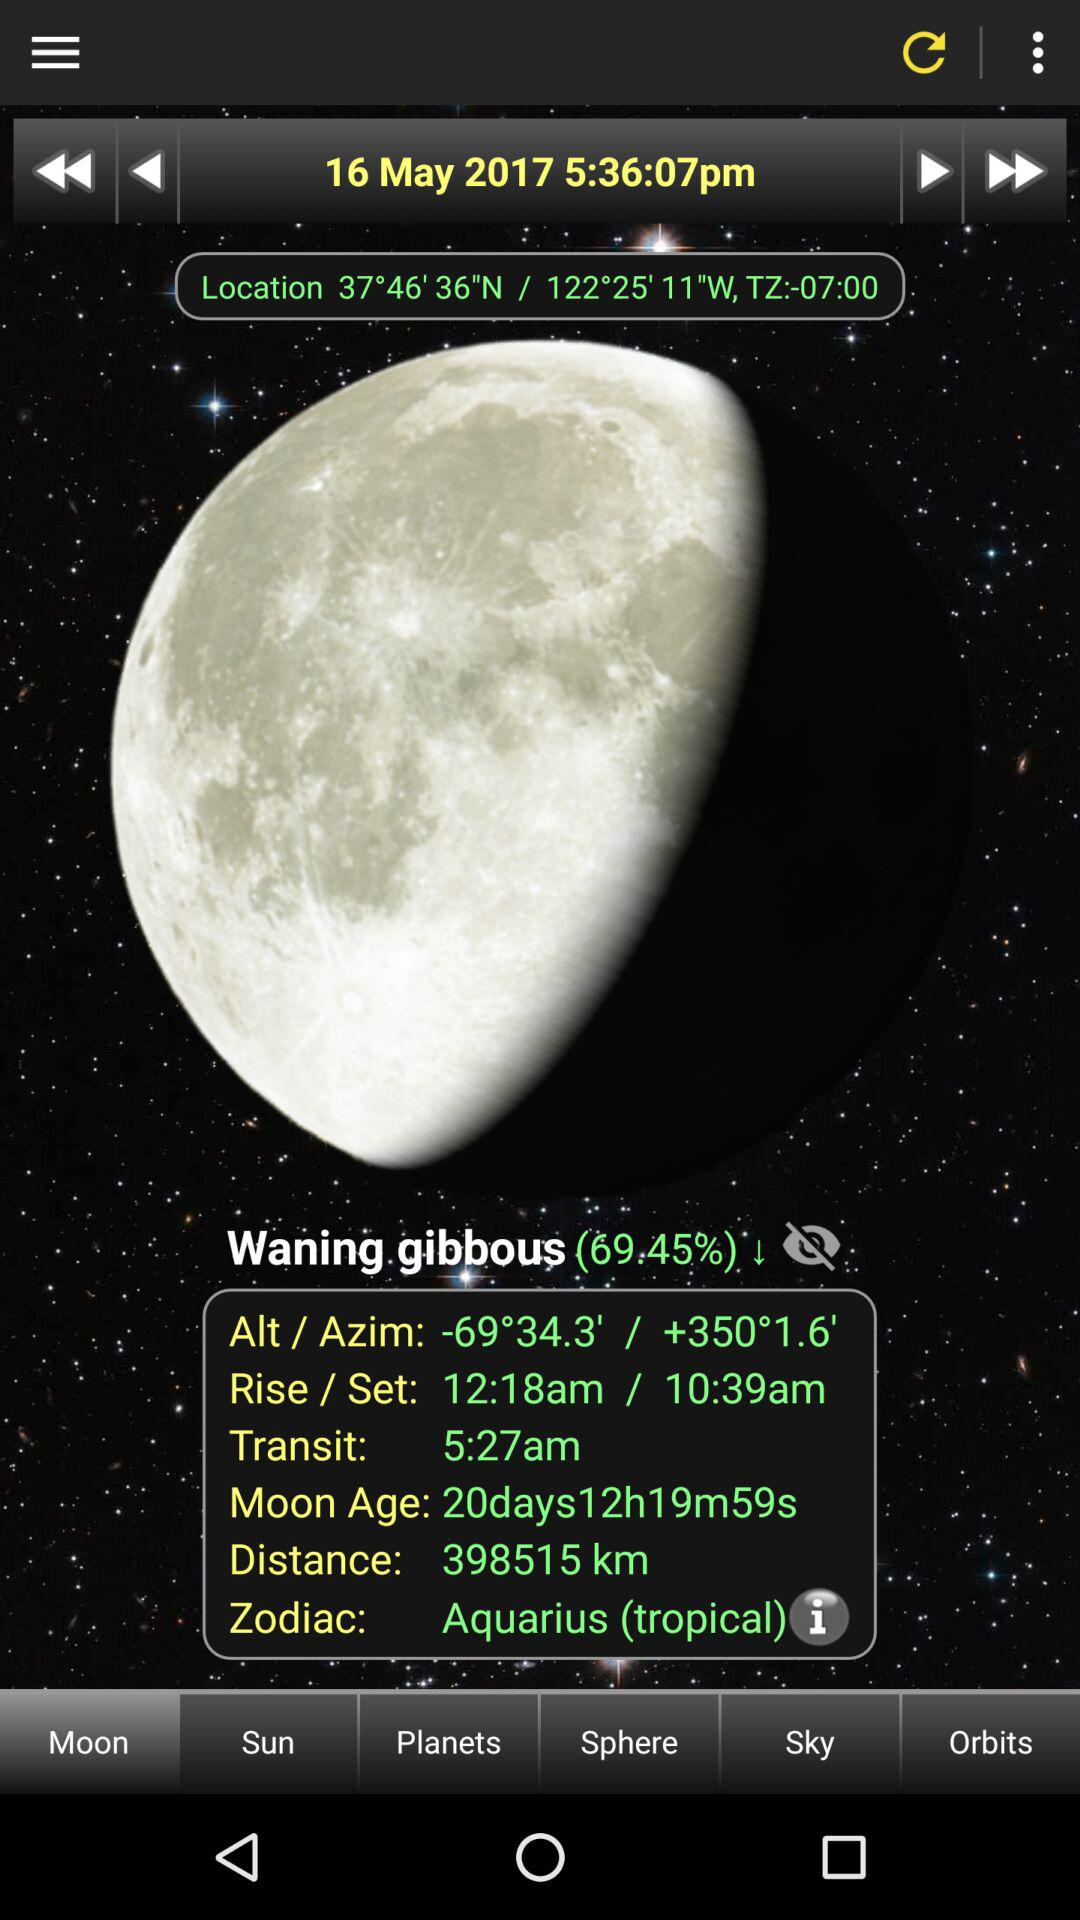What is the moon age? The moon age is 20 days 12 hours 19 minutes 59 seconds. 